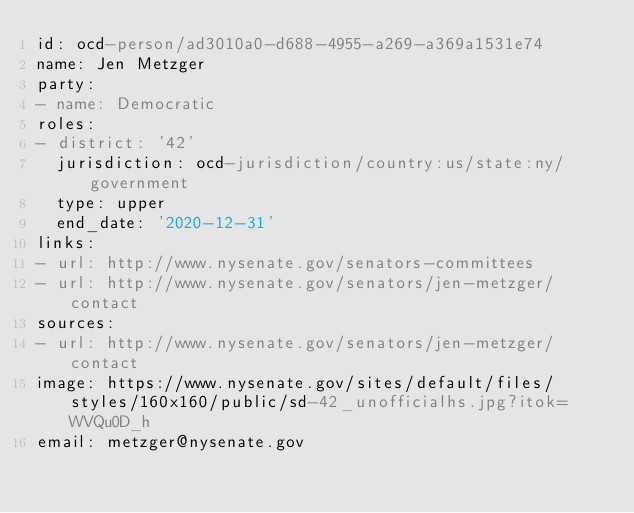Convert code to text. <code><loc_0><loc_0><loc_500><loc_500><_YAML_>id: ocd-person/ad3010a0-d688-4955-a269-a369a1531e74
name: Jen Metzger
party:
- name: Democratic
roles:
- district: '42'
  jurisdiction: ocd-jurisdiction/country:us/state:ny/government
  type: upper
  end_date: '2020-12-31'
links:
- url: http://www.nysenate.gov/senators-committees
- url: http://www.nysenate.gov/senators/jen-metzger/contact
sources:
- url: http://www.nysenate.gov/senators/jen-metzger/contact
image: https://www.nysenate.gov/sites/default/files/styles/160x160/public/sd-42_unofficialhs.jpg?itok=WVQu0D_h
email: metzger@nysenate.gov
</code> 